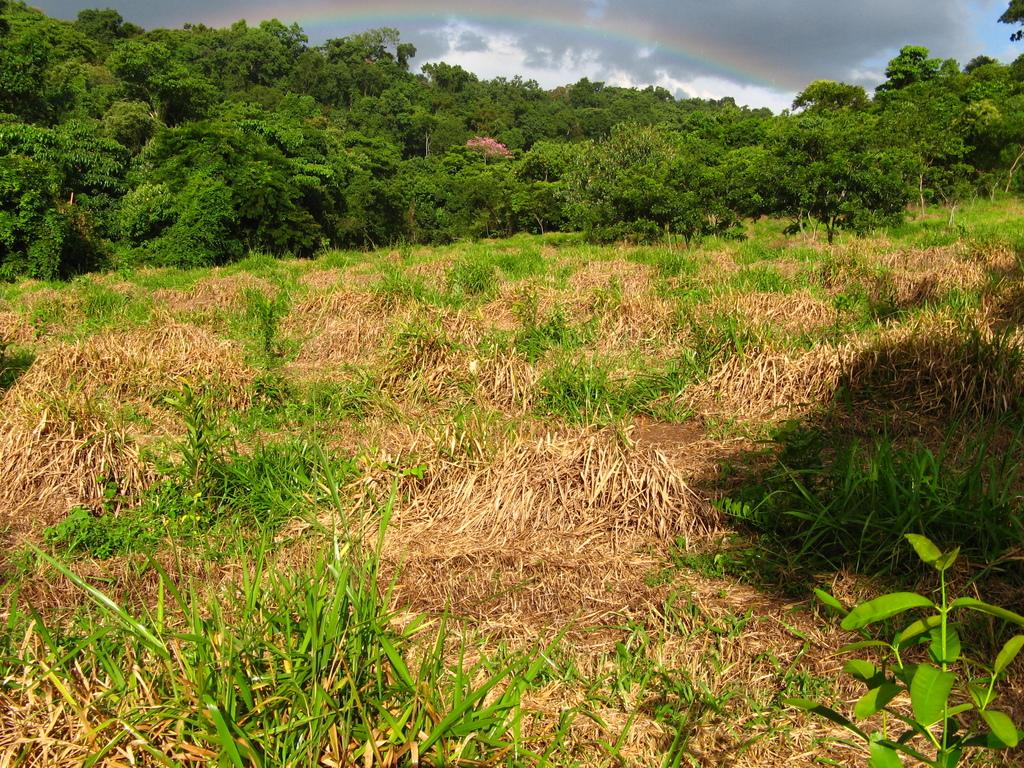What type of vegetation is at the bottom of the image? There is grass at the bottom of the image. What can be seen in the background of the image? There are trees and the sky visible in the background of the image. What additional feature is present in the background of the image? There is a rainbow in the background of the image. What type of game is being played on the grass in the image? There is no game being played in the image; it only shows grass, trees, sky, and a rainbow. 